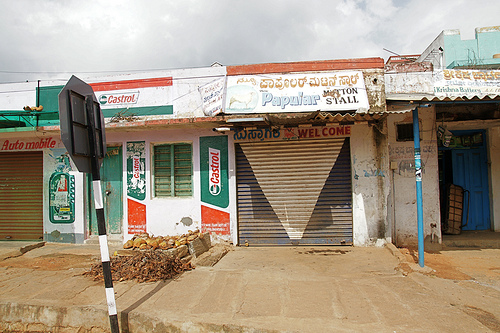Extract all visible text content from this image. Castrol Papniar STALL WELCOME Castrol MUTTON Castrol Auto mobile 